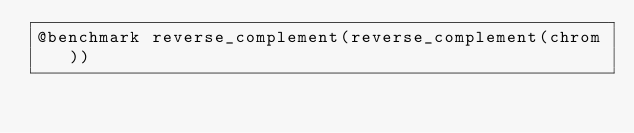Convert code to text. <code><loc_0><loc_0><loc_500><loc_500><_Julia_>@benchmark reverse_complement(reverse_complement(chrom))
</code> 